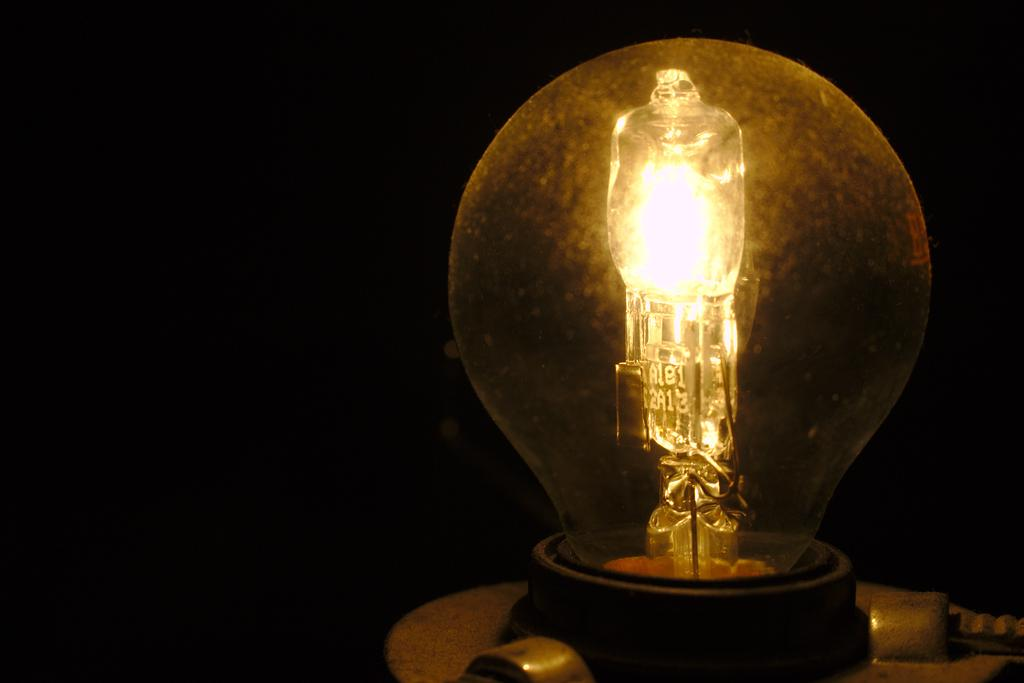What object is the main focus of the image? There is a bulb in the image. What can be observed about the lighting conditions in the image? The background of the image is dark. Reasoning: Let' Let's think step by step in order to produce the conversation. We start by identifying the main subject of the image, which is the bulb. Then, we describe the lighting conditions in the image, noting that the background is dark. We avoid yes/no questions and ensure that the language is simple and clear. Absurd Question/Answer: What type of guitar is being played in the image? There is no guitar present in the image; it only features a bulb. How many cherries are visible on the bulb in the image? There are no cherries present in the image; it only features a bulb. How many cherries are visible on the bulb in the image? There are no cherries present in the image; it only features a bulb. 